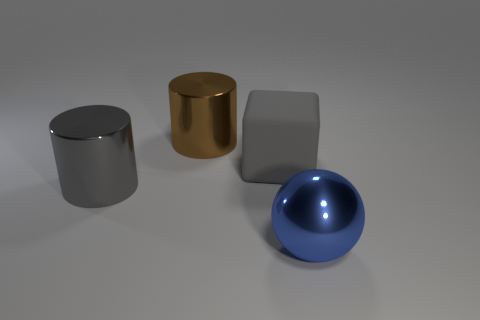There is a cylinder in front of the big brown cylinder; does it have the same color as the big block that is right of the brown object?
Offer a terse response. Yes. How many other objects are there of the same material as the gray cube?
Provide a succinct answer. 0. There is a gray object that is the same shape as the brown metallic thing; what material is it?
Keep it short and to the point. Metal. Does the cylinder in front of the matte block have the same color as the big matte object?
Offer a very short reply. Yes. What is the sphere made of?
Provide a succinct answer. Metal. There is a block that is the same size as the blue shiny thing; what is its material?
Ensure brevity in your answer.  Rubber. Is there a gray matte ball that has the same size as the brown object?
Your answer should be compact. No. Are there an equal number of large brown cylinders that are to the left of the gray cylinder and gray things behind the big brown cylinder?
Ensure brevity in your answer.  Yes. Is the number of brown rubber spheres greater than the number of large brown shiny cylinders?
Your answer should be compact. No. What number of shiny things are big blue things or cylinders?
Your response must be concise. 3. 